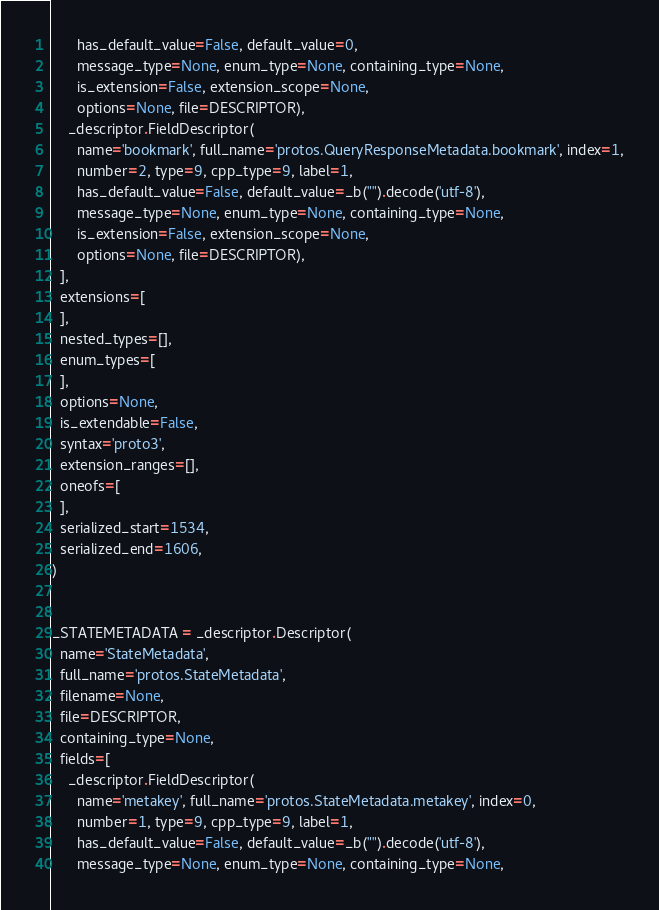<code> <loc_0><loc_0><loc_500><loc_500><_Python_>      has_default_value=False, default_value=0,
      message_type=None, enum_type=None, containing_type=None,
      is_extension=False, extension_scope=None,
      options=None, file=DESCRIPTOR),
    _descriptor.FieldDescriptor(
      name='bookmark', full_name='protos.QueryResponseMetadata.bookmark', index=1,
      number=2, type=9, cpp_type=9, label=1,
      has_default_value=False, default_value=_b("").decode('utf-8'),
      message_type=None, enum_type=None, containing_type=None,
      is_extension=False, extension_scope=None,
      options=None, file=DESCRIPTOR),
  ],
  extensions=[
  ],
  nested_types=[],
  enum_types=[
  ],
  options=None,
  is_extendable=False,
  syntax='proto3',
  extension_ranges=[],
  oneofs=[
  ],
  serialized_start=1534,
  serialized_end=1606,
)


_STATEMETADATA = _descriptor.Descriptor(
  name='StateMetadata',
  full_name='protos.StateMetadata',
  filename=None,
  file=DESCRIPTOR,
  containing_type=None,
  fields=[
    _descriptor.FieldDescriptor(
      name='metakey', full_name='protos.StateMetadata.metakey', index=0,
      number=1, type=9, cpp_type=9, label=1,
      has_default_value=False, default_value=_b("").decode('utf-8'),
      message_type=None, enum_type=None, containing_type=None,</code> 